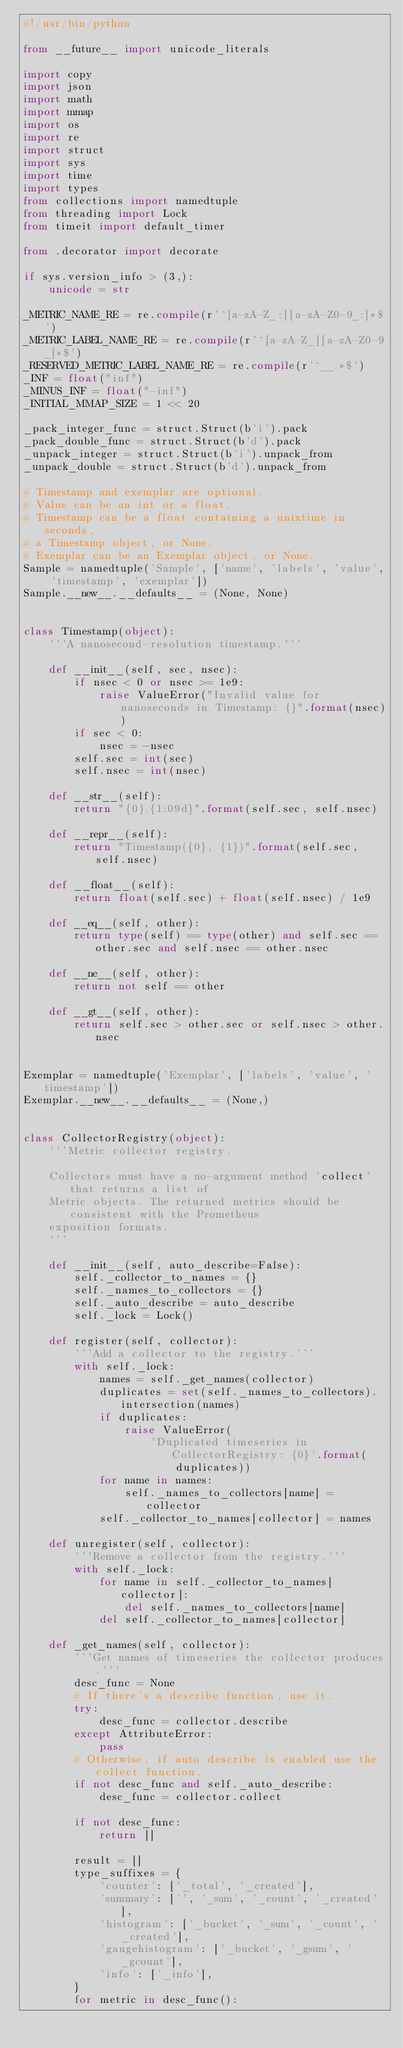<code> <loc_0><loc_0><loc_500><loc_500><_Python_>#!/usr/bin/python

from __future__ import unicode_literals

import copy
import json
import math
import mmap
import os
import re
import struct
import sys
import time
import types
from collections import namedtuple
from threading import Lock
from timeit import default_timer

from .decorator import decorate

if sys.version_info > (3,):
    unicode = str

_METRIC_NAME_RE = re.compile(r'^[a-zA-Z_:][a-zA-Z0-9_:]*$')
_METRIC_LABEL_NAME_RE = re.compile(r'^[a-zA-Z_][a-zA-Z0-9_]*$')
_RESERVED_METRIC_LABEL_NAME_RE = re.compile(r'^__.*$')
_INF = float("inf")
_MINUS_INF = float("-inf")
_INITIAL_MMAP_SIZE = 1 << 20

_pack_integer_func = struct.Struct(b'i').pack
_pack_double_func = struct.Struct(b'd').pack
_unpack_integer = struct.Struct(b'i').unpack_from
_unpack_double = struct.Struct(b'd').unpack_from

# Timestamp and exemplar are optional.
# Value can be an int or a float.
# Timestamp can be a float containing a unixtime in seconds,
# a Timestamp object, or None.
# Exemplar can be an Exemplar object, or None.
Sample = namedtuple('Sample', ['name', 'labels', 'value', 'timestamp', 'exemplar'])
Sample.__new__.__defaults__ = (None, None)


class Timestamp(object):
    '''A nanosecond-resolution timestamp.'''

    def __init__(self, sec, nsec):
        if nsec < 0 or nsec >= 1e9:
            raise ValueError("Invalid value for nanoseconds in Timestamp: {}".format(nsec))
        if sec < 0:
            nsec = -nsec
        self.sec = int(sec)
        self.nsec = int(nsec)

    def __str__(self):
        return "{0}.{1:09d}".format(self.sec, self.nsec)

    def __repr__(self):
        return "Timestamp({0}, {1})".format(self.sec, self.nsec)

    def __float__(self):
        return float(self.sec) + float(self.nsec) / 1e9

    def __eq__(self, other):
        return type(self) == type(other) and self.sec == other.sec and self.nsec == other.nsec

    def __ne__(self, other):
        return not self == other

    def __gt__(self, other):
        return self.sec > other.sec or self.nsec > other.nsec


Exemplar = namedtuple('Exemplar', ['labels', 'value', 'timestamp'])
Exemplar.__new__.__defaults__ = (None,)


class CollectorRegistry(object):
    '''Metric collector registry.

    Collectors must have a no-argument method 'collect' that returns a list of
    Metric objects. The returned metrics should be consistent with the Prometheus
    exposition formats.
    '''

    def __init__(self, auto_describe=False):
        self._collector_to_names = {}
        self._names_to_collectors = {}
        self._auto_describe = auto_describe
        self._lock = Lock()

    def register(self, collector):
        '''Add a collector to the registry.'''
        with self._lock:
            names = self._get_names(collector)
            duplicates = set(self._names_to_collectors).intersection(names)
            if duplicates:
                raise ValueError(
                    'Duplicated timeseries in CollectorRegistry: {0}'.format(
                        duplicates))
            for name in names:
                self._names_to_collectors[name] = collector
            self._collector_to_names[collector] = names

    def unregister(self, collector):
        '''Remove a collector from the registry.'''
        with self._lock:
            for name in self._collector_to_names[collector]:
                del self._names_to_collectors[name]
            del self._collector_to_names[collector]

    def _get_names(self, collector):
        '''Get names of timeseries the collector produces.'''
        desc_func = None
        # If there's a describe function, use it.
        try:
            desc_func = collector.describe
        except AttributeError:
            pass
        # Otherwise, if auto describe is enabled use the collect function.
        if not desc_func and self._auto_describe:
            desc_func = collector.collect

        if not desc_func:
            return []

        result = []
        type_suffixes = {
            'counter': ['_total', '_created'],
            'summary': ['', '_sum', '_count', '_created'],
            'histogram': ['_bucket', '_sum', '_count', '_created'],
            'gaugehistogram': ['_bucket', '_gsum', '_gcount'],
            'info': ['_info'],
        }
        for metric in desc_func():</code> 